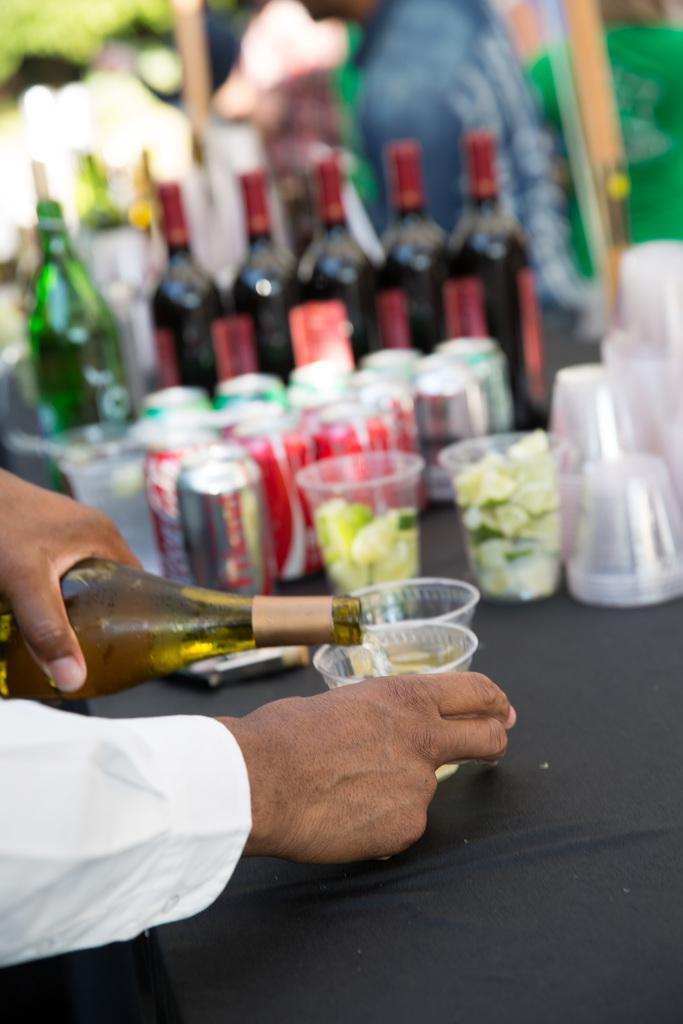Provide a one-sentence caption for the provided image. A man pouring some type of alcohol into a small cup with Coca-Cola and other drinks sitting on the table in the background. 